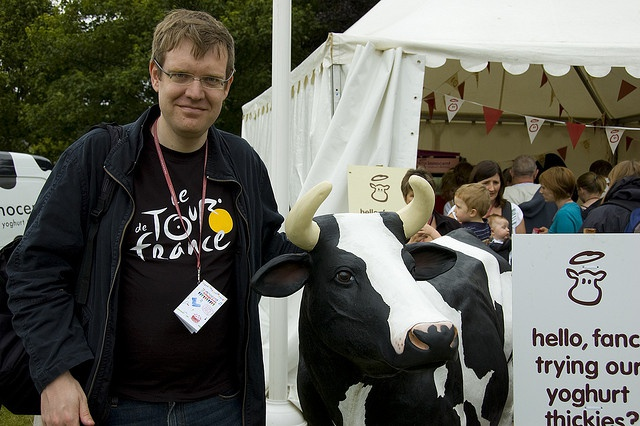Describe the objects in this image and their specific colors. I can see people in black and gray tones, cow in black, white, gray, and darkgray tones, backpack in black, gray, and lightgray tones, people in black, navy, and gray tones, and people in black, maroon, and teal tones in this image. 